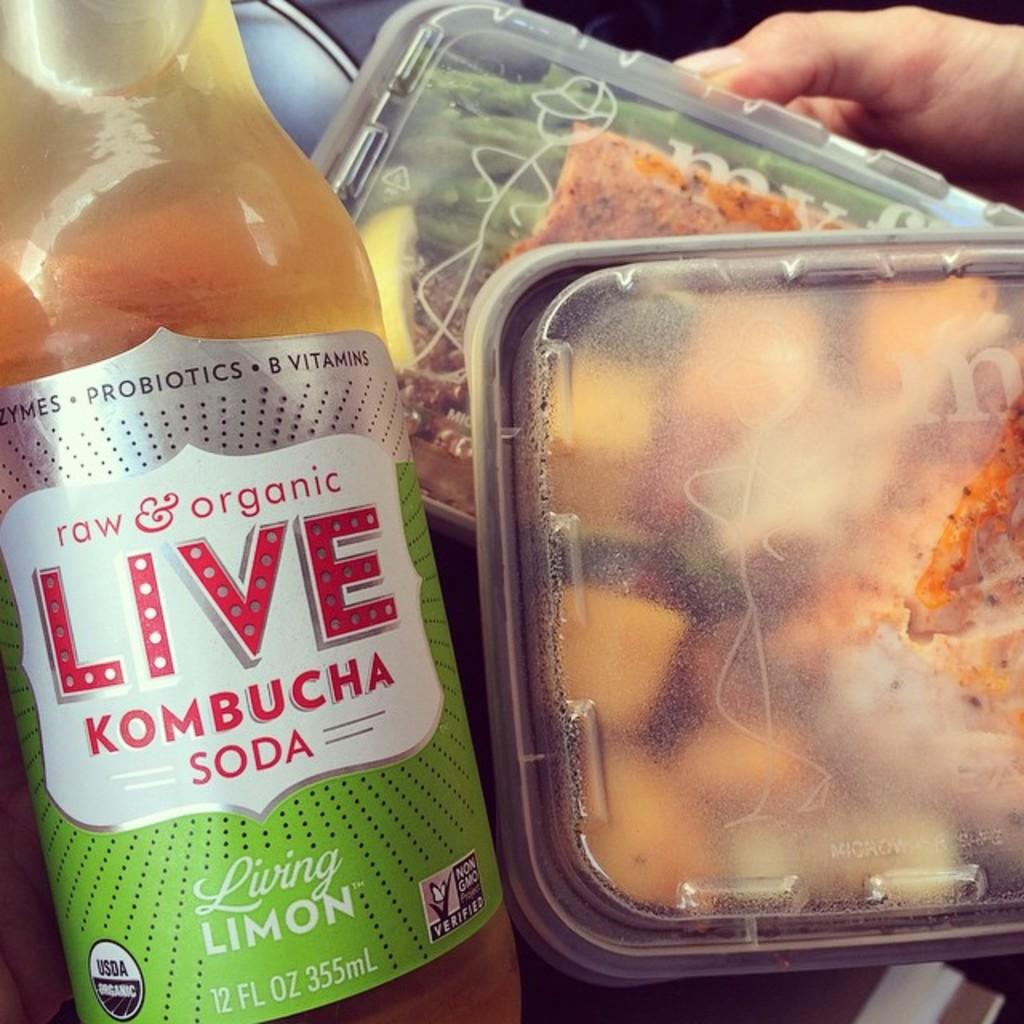<image>
Give a short and clear explanation of the subsequent image. A bottle of raw and organic kombucha soda sits next to food containers 